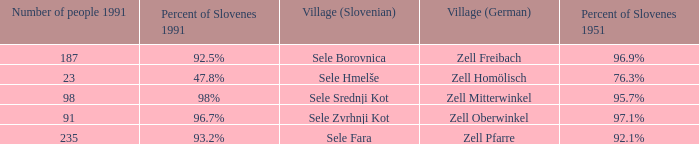Provide with the names of the village (German) that is part of village (Slovenian) with sele srednji kot. Zell Mitterwinkel. 